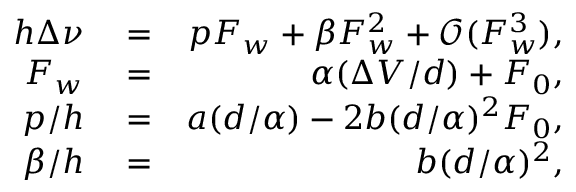<formula> <loc_0><loc_0><loc_500><loc_500>\begin{array} { r l r } { h \Delta \nu } & = } & { p F _ { w } + \beta F _ { w } ^ { 2 } + \mathcal { O } ( F _ { w } ^ { 3 } ) , } \\ { F _ { w } } & = } & { \alpha ( \Delta V / d ) + F _ { 0 } , } \\ { p / h } & = } & { a ( d / \alpha ) - 2 b ( d / \alpha ) ^ { 2 } F _ { 0 } , } \\ { \beta / h } & = } & { b ( d / \alpha ) ^ { 2 } , } \end{array}</formula> 